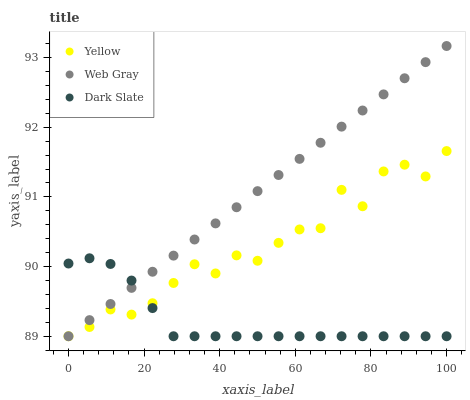Does Dark Slate have the minimum area under the curve?
Answer yes or no. Yes. Does Web Gray have the maximum area under the curve?
Answer yes or no. Yes. Does Yellow have the minimum area under the curve?
Answer yes or no. No. Does Yellow have the maximum area under the curve?
Answer yes or no. No. Is Web Gray the smoothest?
Answer yes or no. Yes. Is Yellow the roughest?
Answer yes or no. Yes. Is Yellow the smoothest?
Answer yes or no. No. Is Web Gray the roughest?
Answer yes or no. No. Does Dark Slate have the lowest value?
Answer yes or no. Yes. Does Web Gray have the highest value?
Answer yes or no. Yes. Does Yellow have the highest value?
Answer yes or no. No. Does Yellow intersect Web Gray?
Answer yes or no. Yes. Is Yellow less than Web Gray?
Answer yes or no. No. Is Yellow greater than Web Gray?
Answer yes or no. No. 